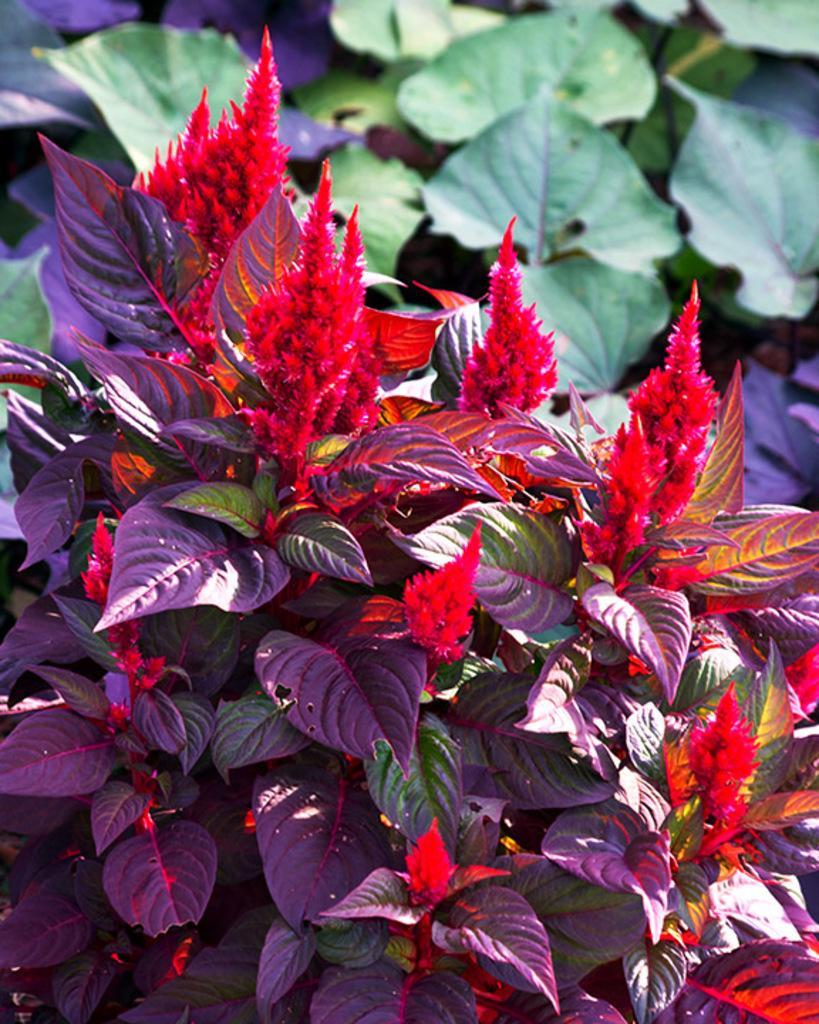How would you summarize this image in a sentence or two? In this picture I can see there are some plants and there are some flowers to the plants. 